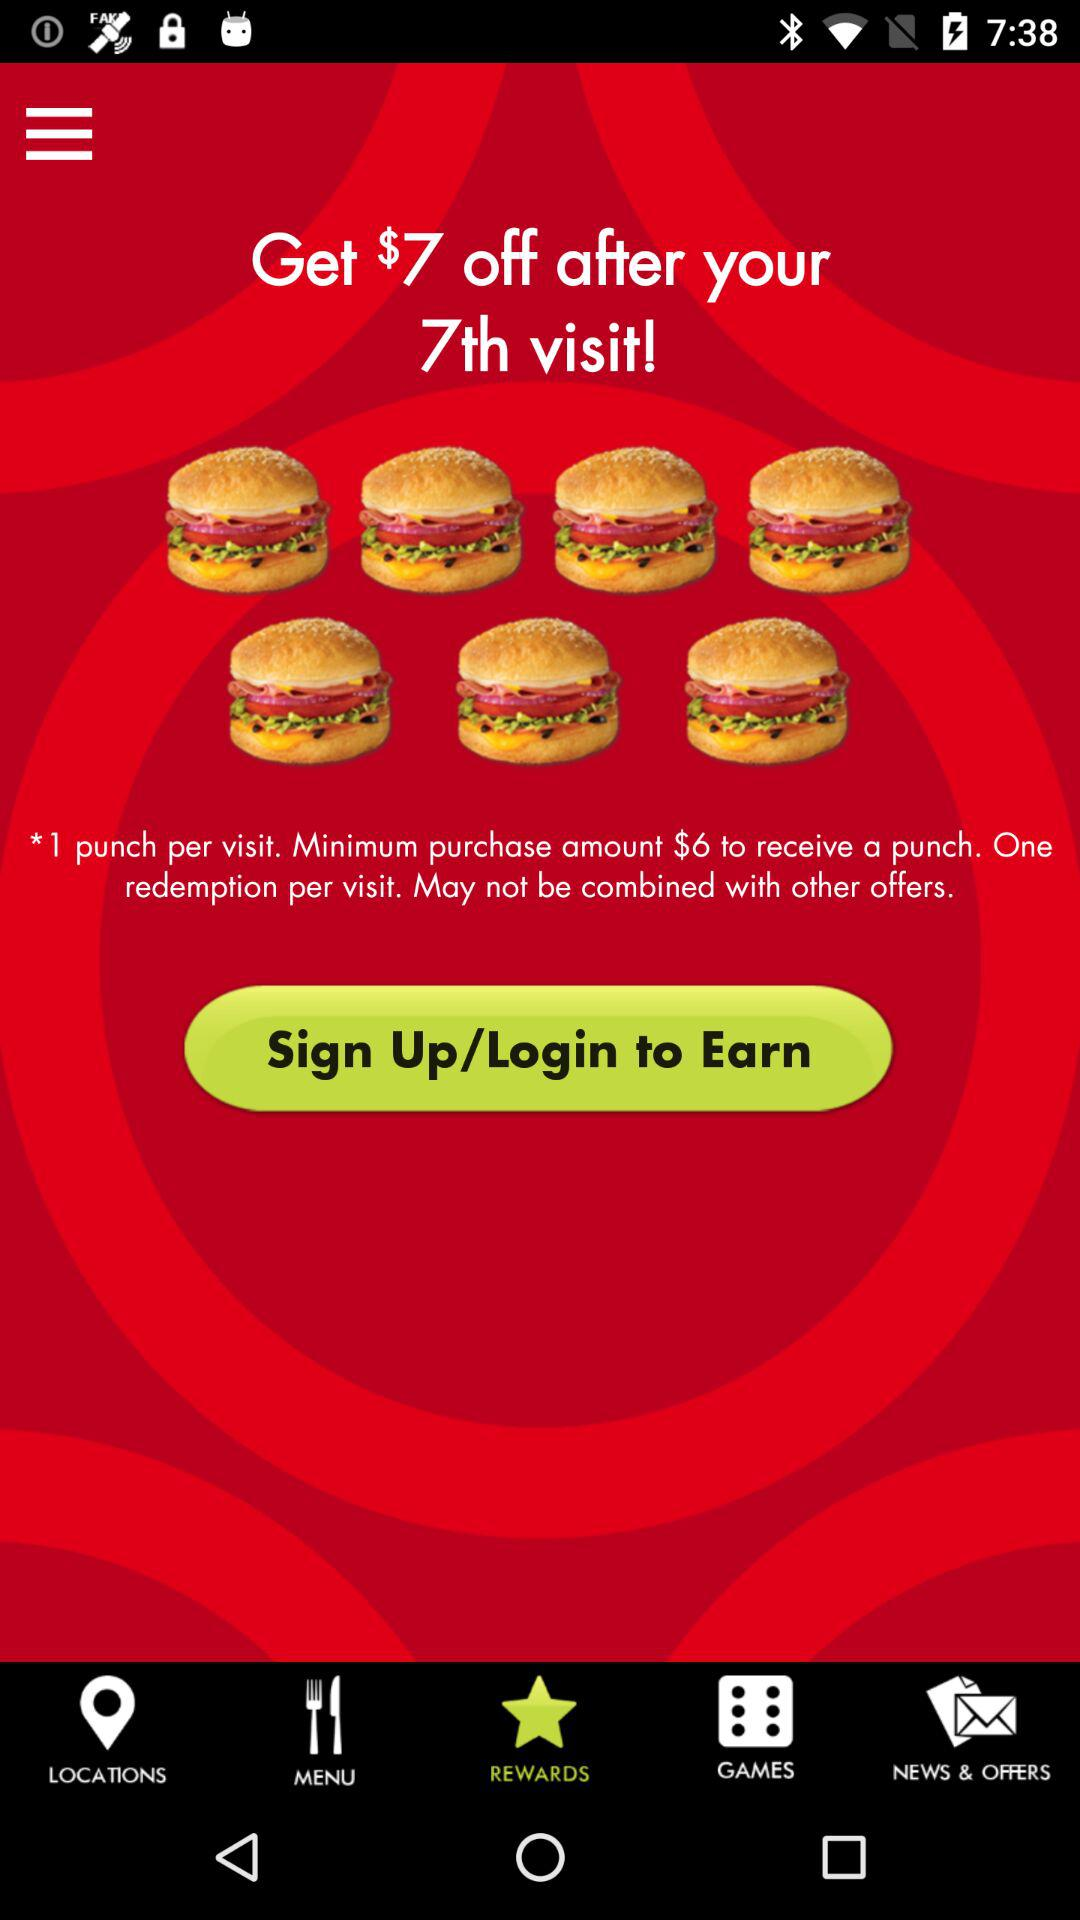How many visits do I need to make to get the offer?
Answer the question using a single word or phrase. 7 